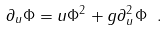<formula> <loc_0><loc_0><loc_500><loc_500>\partial _ { u } \Phi = u \Phi ^ { 2 } + g \partial _ { u } ^ { 2 } \Phi \ . \label l { e q \colon 1 m s d }</formula> 